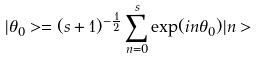<formula> <loc_0><loc_0><loc_500><loc_500>| \theta _ { 0 } > = ( s + 1 ) ^ { - \frac { 1 } { 2 } } \sum ^ { s } _ { n = 0 } \exp ( i n \theta _ { 0 } ) | n ></formula> 